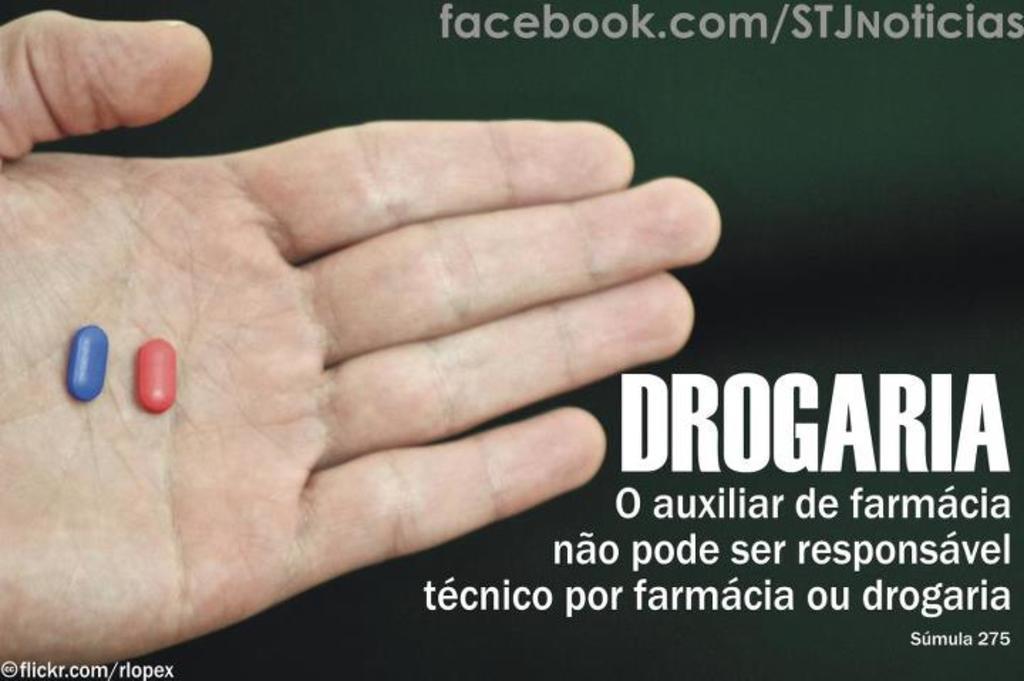In one or two sentences, can you explain what this image depicts? In the image there is a poster. On the left side of the image there is a hand with pills. And on the poster there is some text on it. 